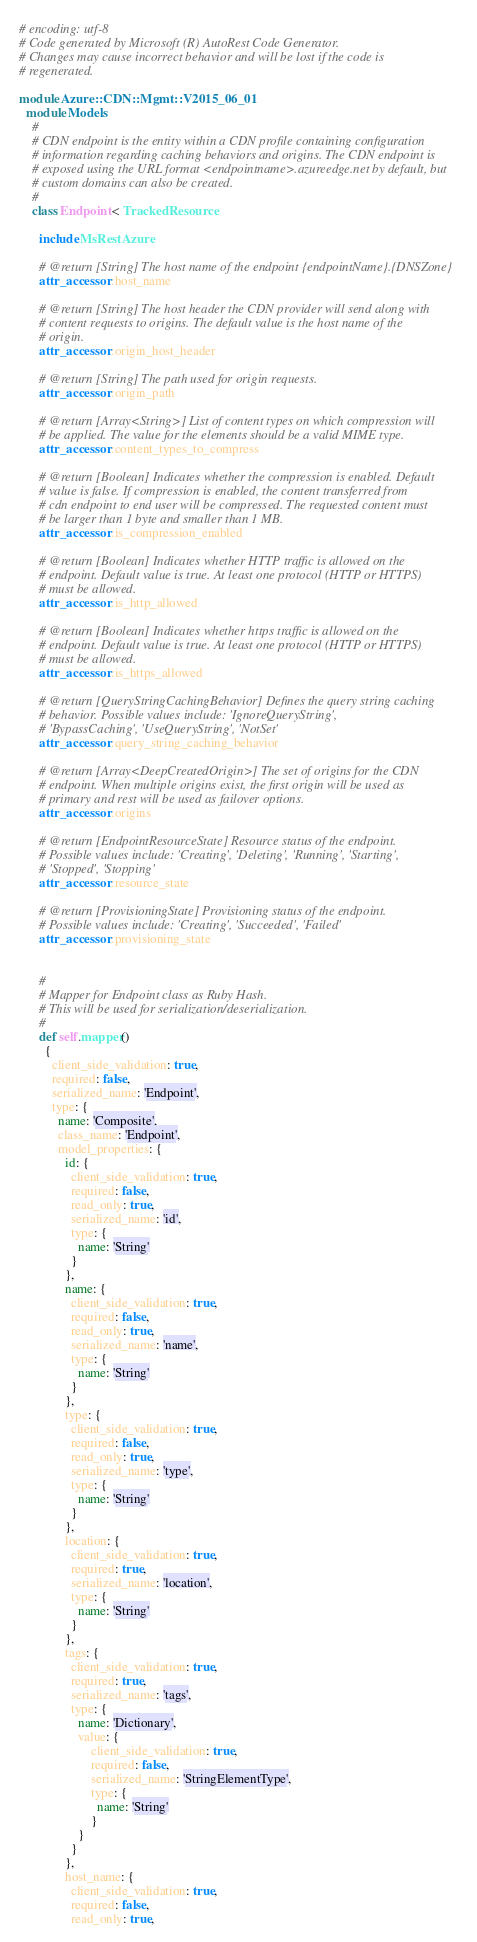Convert code to text. <code><loc_0><loc_0><loc_500><loc_500><_Ruby_># encoding: utf-8
# Code generated by Microsoft (R) AutoRest Code Generator.
# Changes may cause incorrect behavior and will be lost if the code is
# regenerated.

module Azure::CDN::Mgmt::V2015_06_01
  module Models
    #
    # CDN endpoint is the entity within a CDN profile containing configuration
    # information regarding caching behaviors and origins. The CDN endpoint is
    # exposed using the URL format <endpointname>.azureedge.net by default, but
    # custom domains can also be created.
    #
    class Endpoint < TrackedResource

      include MsRestAzure

      # @return [String] The host name of the endpoint {endpointName}.{DNSZone}
      attr_accessor :host_name

      # @return [String] The host header the CDN provider will send along with
      # content requests to origins. The default value is the host name of the
      # origin.
      attr_accessor :origin_host_header

      # @return [String] The path used for origin requests.
      attr_accessor :origin_path

      # @return [Array<String>] List of content types on which compression will
      # be applied. The value for the elements should be a valid MIME type.
      attr_accessor :content_types_to_compress

      # @return [Boolean] Indicates whether the compression is enabled. Default
      # value is false. If compression is enabled, the content transferred from
      # cdn endpoint to end user will be compressed. The requested content must
      # be larger than 1 byte and smaller than 1 MB.
      attr_accessor :is_compression_enabled

      # @return [Boolean] Indicates whether HTTP traffic is allowed on the
      # endpoint. Default value is true. At least one protocol (HTTP or HTTPS)
      # must be allowed.
      attr_accessor :is_http_allowed

      # @return [Boolean] Indicates whether https traffic is allowed on the
      # endpoint. Default value is true. At least one protocol (HTTP or HTTPS)
      # must be allowed.
      attr_accessor :is_https_allowed

      # @return [QueryStringCachingBehavior] Defines the query string caching
      # behavior. Possible values include: 'IgnoreQueryString',
      # 'BypassCaching', 'UseQueryString', 'NotSet'
      attr_accessor :query_string_caching_behavior

      # @return [Array<DeepCreatedOrigin>] The set of origins for the CDN
      # endpoint. When multiple origins exist, the first origin will be used as
      # primary and rest will be used as failover options.
      attr_accessor :origins

      # @return [EndpointResourceState] Resource status of the endpoint.
      # Possible values include: 'Creating', 'Deleting', 'Running', 'Starting',
      # 'Stopped', 'Stopping'
      attr_accessor :resource_state

      # @return [ProvisioningState] Provisioning status of the endpoint.
      # Possible values include: 'Creating', 'Succeeded', 'Failed'
      attr_accessor :provisioning_state


      #
      # Mapper for Endpoint class as Ruby Hash.
      # This will be used for serialization/deserialization.
      #
      def self.mapper()
        {
          client_side_validation: true,
          required: false,
          serialized_name: 'Endpoint',
          type: {
            name: 'Composite',
            class_name: 'Endpoint',
            model_properties: {
              id: {
                client_side_validation: true,
                required: false,
                read_only: true,
                serialized_name: 'id',
                type: {
                  name: 'String'
                }
              },
              name: {
                client_side_validation: true,
                required: false,
                read_only: true,
                serialized_name: 'name',
                type: {
                  name: 'String'
                }
              },
              type: {
                client_side_validation: true,
                required: false,
                read_only: true,
                serialized_name: 'type',
                type: {
                  name: 'String'
                }
              },
              location: {
                client_side_validation: true,
                required: true,
                serialized_name: 'location',
                type: {
                  name: 'String'
                }
              },
              tags: {
                client_side_validation: true,
                required: true,
                serialized_name: 'tags',
                type: {
                  name: 'Dictionary',
                  value: {
                      client_side_validation: true,
                      required: false,
                      serialized_name: 'StringElementType',
                      type: {
                        name: 'String'
                      }
                  }
                }
              },
              host_name: {
                client_side_validation: true,
                required: false,
                read_only: true,</code> 